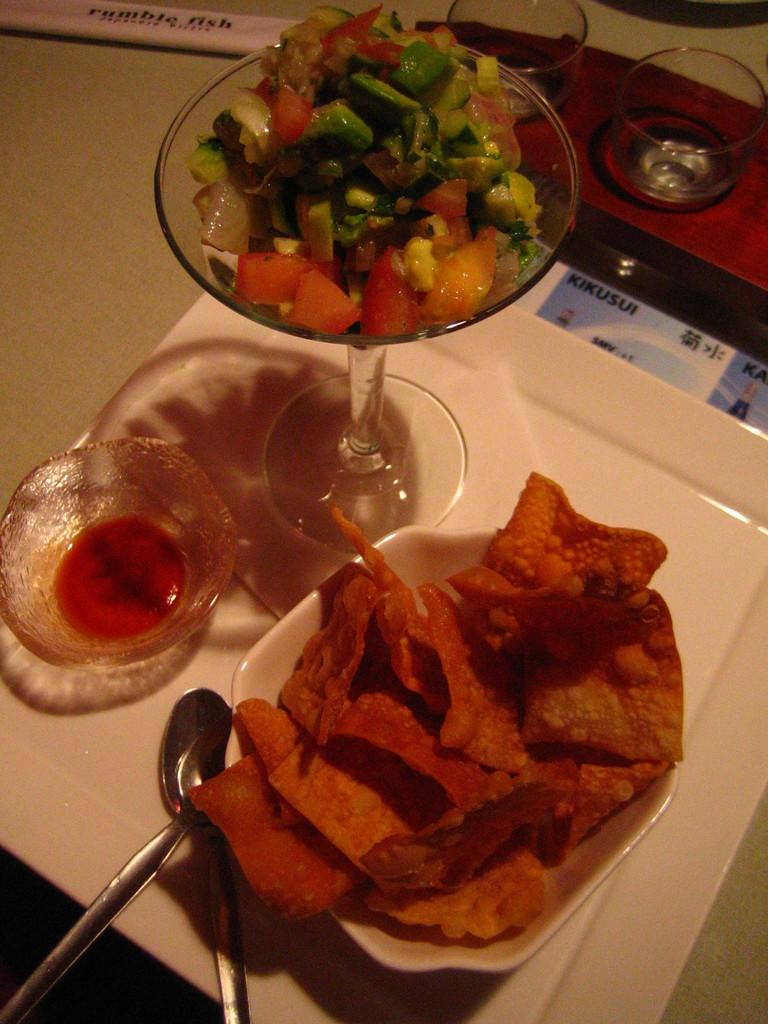What type of furniture is present in the image? There is a table in the image. What can be seen on the table? There are glasses, a plate, a bowl, spoons, food items, and other objects on the table. Can you describe the food items on the table? The food items on the table are not specified, but they are present. Reasoning: Let's think step by identifying the main subjects and objects in the image based on the provided facts. We then formulate questions that focus on the location and characteristics of these subjects and objects, ensuring that each question can be answered definitively with the information given. We avoid yes/no questions and ensure that the language is simple and clear. Absurd Question/Answer: What type of mark can be seen on the design of the table in the image? There is no mention of a mark or design on the table in the image; it is simply described as a table with various items on it. What type of milk is being served in the glasses on the table in the image? There is no mention of milk or any specific food items in the image; only glasses, a plate, a bowl, spoons, food items, and other objects are mentioned. 